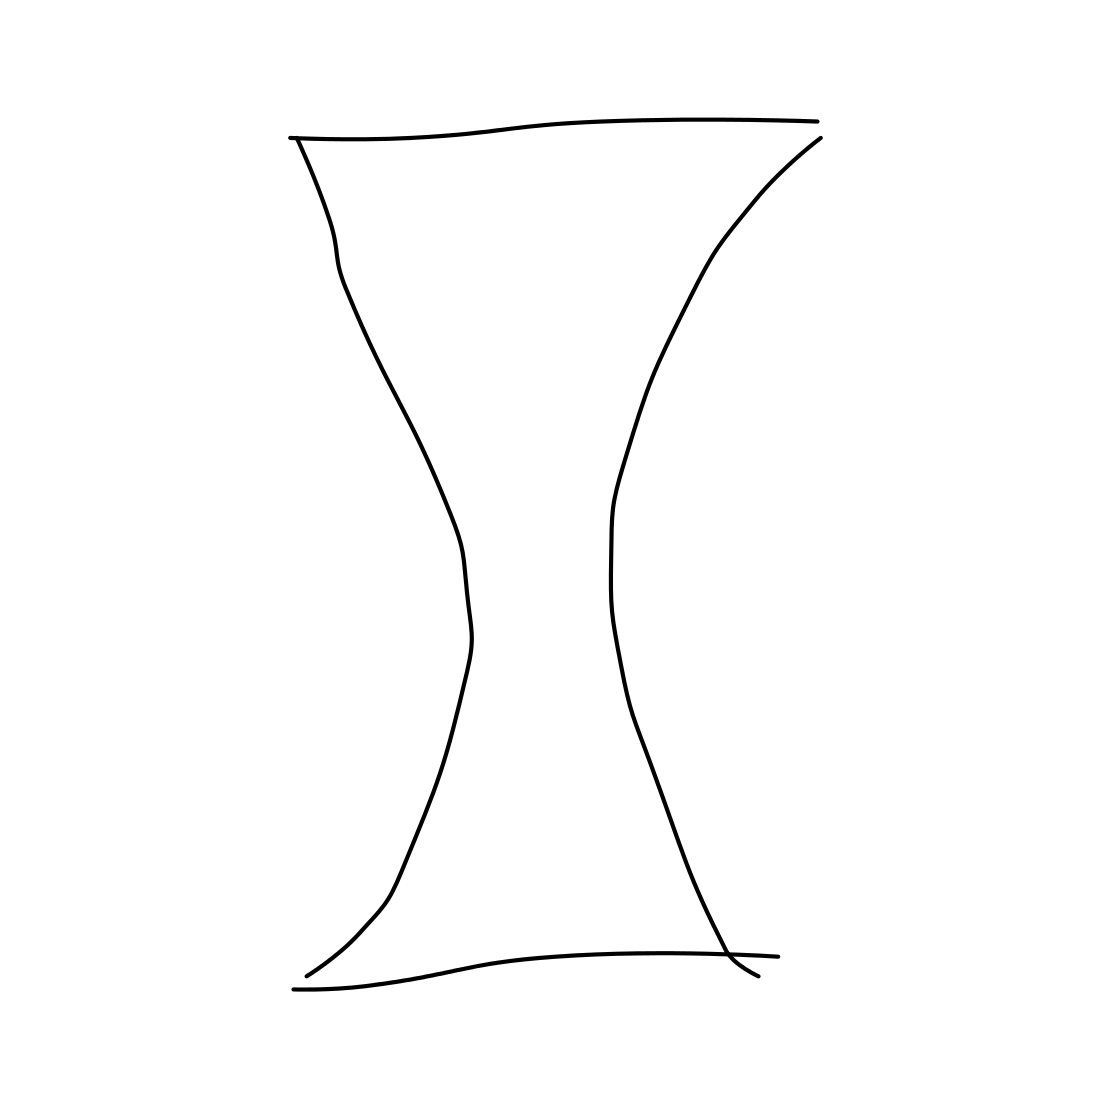What could this shape represent symbolically? The hourglass shape can symbolize the concept of time or the passage of it, as it's often associated with the traditional hourglass timekeeping device. It might also represent balance, with the symmetrical tapering towards the center resembling equilibrium. 